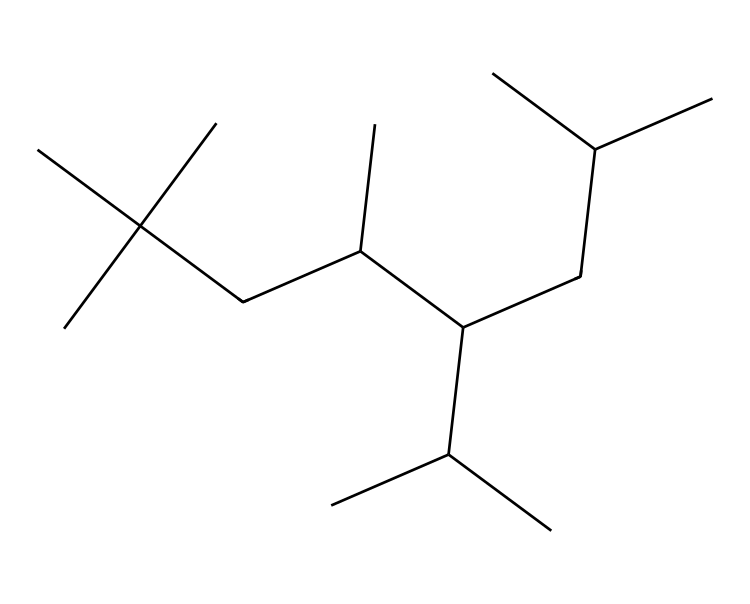What is the molecular formula of the compound? To determine the molecular formula from the SMILES, we count the carbon (C) and hydrogen (H) atoms in the structure. The given SMILES indicates a hydrocarbon with multiple branched chains, leading to a molecular formula of C18H38.
Answer: C18H38 How many total carbon atoms are present? By examining the SMILES notation closely, we can identify each 'C' in the structure. Counting them reveals that there are a total of 18 carbon atoms.
Answer: 18 What type of strands are present in PAO lubricants? Observing the branched structure in the SMILES notation, it indicates that the lubricant is a synthetic hydrocarbon, specifically a branched alkane. This structure is typical for polyalphaolefins (PAOs), commonly used as lubricants.
Answer: branched alkane What is the main advantage of using PAO lubricants? PAO lubricants exhibit excellent thermal stability and low volatility, which makes them ideal for high-performance applications such as maintaining 3D printing equipment in animation studios, where consistent performance is crucial.
Answer: thermal stability Why does the branching in PAOs affect their lubricating properties? The branching in PAO structures reduces the intermolecular forces, allowing for a lower viscosity at high temperatures and improving flow characteristics. This is especially beneficial in preventing wear in machinery such as 3D printers.
Answer: reduces intermolecular forces How does the synthetic nature of PAO lubricants contribute to their performance? Being synthetic, PAOs can be engineered for specific properties, such as enhanced lubricity and better performance under extreme conditions compared to conventional mineral oil-based lubricants, making them more effective for 3D printing equipment.
Answer: engineered for specific properties 